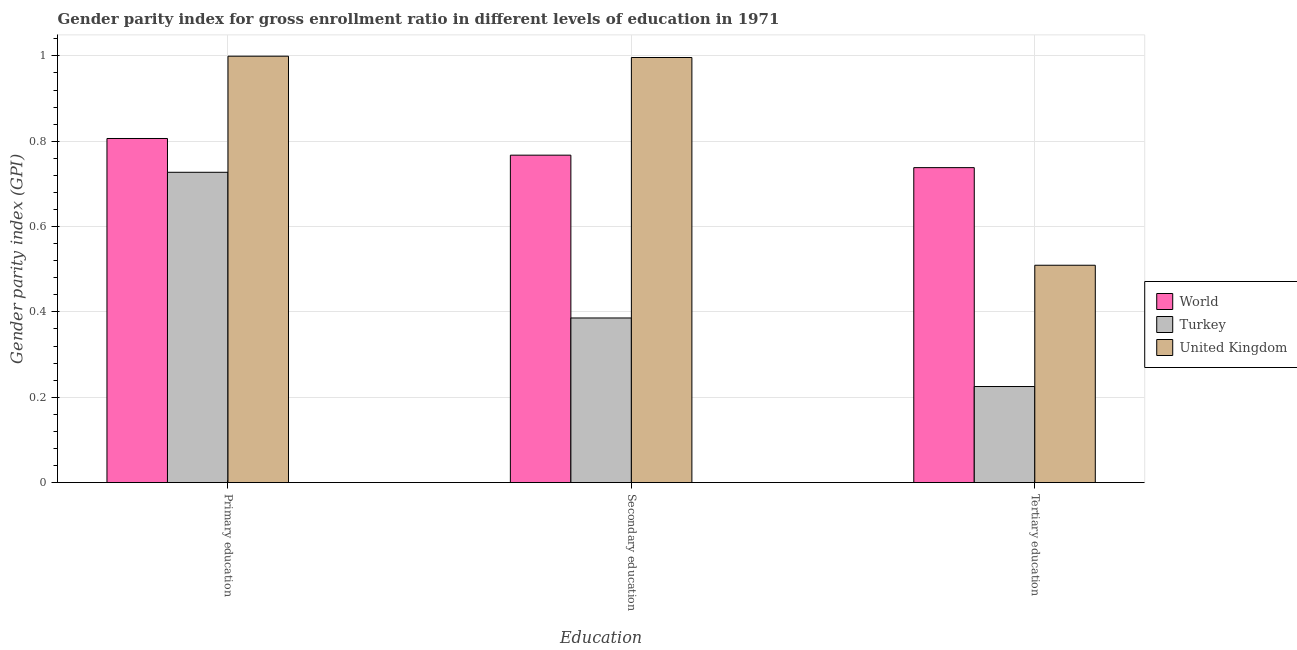How many different coloured bars are there?
Keep it short and to the point. 3. How many groups of bars are there?
Make the answer very short. 3. How many bars are there on the 3rd tick from the right?
Keep it short and to the point. 3. What is the label of the 3rd group of bars from the left?
Your answer should be very brief. Tertiary education. What is the gender parity index in primary education in United Kingdom?
Offer a terse response. 1. Across all countries, what is the maximum gender parity index in secondary education?
Your answer should be compact. 1. Across all countries, what is the minimum gender parity index in secondary education?
Provide a short and direct response. 0.39. What is the total gender parity index in primary education in the graph?
Ensure brevity in your answer.  2.53. What is the difference between the gender parity index in primary education in United Kingdom and that in World?
Ensure brevity in your answer.  0.19. What is the difference between the gender parity index in secondary education in United Kingdom and the gender parity index in primary education in Turkey?
Offer a very short reply. 0.27. What is the average gender parity index in secondary education per country?
Provide a short and direct response. 0.72. What is the difference between the gender parity index in secondary education and gender parity index in tertiary education in United Kingdom?
Give a very brief answer. 0.49. What is the ratio of the gender parity index in secondary education in United Kingdom to that in World?
Provide a succinct answer. 1.3. Is the gender parity index in tertiary education in Turkey less than that in World?
Provide a short and direct response. Yes. What is the difference between the highest and the second highest gender parity index in tertiary education?
Your answer should be very brief. 0.23. What is the difference between the highest and the lowest gender parity index in primary education?
Your answer should be very brief. 0.27. What does the 3rd bar from the right in Primary education represents?
Your response must be concise. World. Is it the case that in every country, the sum of the gender parity index in primary education and gender parity index in secondary education is greater than the gender parity index in tertiary education?
Make the answer very short. Yes. Are all the bars in the graph horizontal?
Offer a very short reply. No. What is the difference between two consecutive major ticks on the Y-axis?
Make the answer very short. 0.2. Does the graph contain grids?
Provide a short and direct response. Yes. Where does the legend appear in the graph?
Make the answer very short. Center right. How many legend labels are there?
Keep it short and to the point. 3. What is the title of the graph?
Make the answer very short. Gender parity index for gross enrollment ratio in different levels of education in 1971. What is the label or title of the X-axis?
Offer a terse response. Education. What is the label or title of the Y-axis?
Provide a succinct answer. Gender parity index (GPI). What is the Gender parity index (GPI) of World in Primary education?
Offer a terse response. 0.81. What is the Gender parity index (GPI) in Turkey in Primary education?
Make the answer very short. 0.73. What is the Gender parity index (GPI) of United Kingdom in Primary education?
Offer a terse response. 1. What is the Gender parity index (GPI) of World in Secondary education?
Your response must be concise. 0.77. What is the Gender parity index (GPI) of Turkey in Secondary education?
Your response must be concise. 0.39. What is the Gender parity index (GPI) in United Kingdom in Secondary education?
Your answer should be very brief. 1. What is the Gender parity index (GPI) in World in Tertiary education?
Your response must be concise. 0.74. What is the Gender parity index (GPI) of Turkey in Tertiary education?
Your answer should be very brief. 0.23. What is the Gender parity index (GPI) of United Kingdom in Tertiary education?
Your response must be concise. 0.51. Across all Education, what is the maximum Gender parity index (GPI) in World?
Your response must be concise. 0.81. Across all Education, what is the maximum Gender parity index (GPI) in Turkey?
Make the answer very short. 0.73. Across all Education, what is the maximum Gender parity index (GPI) of United Kingdom?
Your answer should be compact. 1. Across all Education, what is the minimum Gender parity index (GPI) of World?
Make the answer very short. 0.74. Across all Education, what is the minimum Gender parity index (GPI) in Turkey?
Offer a terse response. 0.23. Across all Education, what is the minimum Gender parity index (GPI) of United Kingdom?
Provide a succinct answer. 0.51. What is the total Gender parity index (GPI) of World in the graph?
Your response must be concise. 2.31. What is the total Gender parity index (GPI) of Turkey in the graph?
Your response must be concise. 1.34. What is the total Gender parity index (GPI) in United Kingdom in the graph?
Provide a short and direct response. 2.5. What is the difference between the Gender parity index (GPI) of World in Primary education and that in Secondary education?
Make the answer very short. 0.04. What is the difference between the Gender parity index (GPI) in Turkey in Primary education and that in Secondary education?
Offer a very short reply. 0.34. What is the difference between the Gender parity index (GPI) of United Kingdom in Primary education and that in Secondary education?
Keep it short and to the point. 0. What is the difference between the Gender parity index (GPI) in World in Primary education and that in Tertiary education?
Your answer should be compact. 0.07. What is the difference between the Gender parity index (GPI) of Turkey in Primary education and that in Tertiary education?
Provide a short and direct response. 0.5. What is the difference between the Gender parity index (GPI) of United Kingdom in Primary education and that in Tertiary education?
Offer a very short reply. 0.49. What is the difference between the Gender parity index (GPI) in World in Secondary education and that in Tertiary education?
Provide a short and direct response. 0.03. What is the difference between the Gender parity index (GPI) in Turkey in Secondary education and that in Tertiary education?
Keep it short and to the point. 0.16. What is the difference between the Gender parity index (GPI) in United Kingdom in Secondary education and that in Tertiary education?
Offer a very short reply. 0.49. What is the difference between the Gender parity index (GPI) in World in Primary education and the Gender parity index (GPI) in Turkey in Secondary education?
Provide a short and direct response. 0.42. What is the difference between the Gender parity index (GPI) of World in Primary education and the Gender parity index (GPI) of United Kingdom in Secondary education?
Make the answer very short. -0.19. What is the difference between the Gender parity index (GPI) in Turkey in Primary education and the Gender parity index (GPI) in United Kingdom in Secondary education?
Your response must be concise. -0.27. What is the difference between the Gender parity index (GPI) of World in Primary education and the Gender parity index (GPI) of Turkey in Tertiary education?
Keep it short and to the point. 0.58. What is the difference between the Gender parity index (GPI) in World in Primary education and the Gender parity index (GPI) in United Kingdom in Tertiary education?
Make the answer very short. 0.3. What is the difference between the Gender parity index (GPI) of Turkey in Primary education and the Gender parity index (GPI) of United Kingdom in Tertiary education?
Provide a succinct answer. 0.22. What is the difference between the Gender parity index (GPI) in World in Secondary education and the Gender parity index (GPI) in Turkey in Tertiary education?
Provide a succinct answer. 0.54. What is the difference between the Gender parity index (GPI) in World in Secondary education and the Gender parity index (GPI) in United Kingdom in Tertiary education?
Offer a very short reply. 0.26. What is the difference between the Gender parity index (GPI) of Turkey in Secondary education and the Gender parity index (GPI) of United Kingdom in Tertiary education?
Provide a short and direct response. -0.12. What is the average Gender parity index (GPI) in World per Education?
Offer a terse response. 0.77. What is the average Gender parity index (GPI) in Turkey per Education?
Make the answer very short. 0.45. What is the average Gender parity index (GPI) in United Kingdom per Education?
Offer a very short reply. 0.83. What is the difference between the Gender parity index (GPI) in World and Gender parity index (GPI) in Turkey in Primary education?
Your response must be concise. 0.08. What is the difference between the Gender parity index (GPI) of World and Gender parity index (GPI) of United Kingdom in Primary education?
Offer a terse response. -0.19. What is the difference between the Gender parity index (GPI) in Turkey and Gender parity index (GPI) in United Kingdom in Primary education?
Your answer should be very brief. -0.27. What is the difference between the Gender parity index (GPI) in World and Gender parity index (GPI) in Turkey in Secondary education?
Your answer should be compact. 0.38. What is the difference between the Gender parity index (GPI) in World and Gender parity index (GPI) in United Kingdom in Secondary education?
Offer a very short reply. -0.23. What is the difference between the Gender parity index (GPI) in Turkey and Gender parity index (GPI) in United Kingdom in Secondary education?
Ensure brevity in your answer.  -0.61. What is the difference between the Gender parity index (GPI) in World and Gender parity index (GPI) in Turkey in Tertiary education?
Provide a short and direct response. 0.51. What is the difference between the Gender parity index (GPI) in World and Gender parity index (GPI) in United Kingdom in Tertiary education?
Provide a succinct answer. 0.23. What is the difference between the Gender parity index (GPI) of Turkey and Gender parity index (GPI) of United Kingdom in Tertiary education?
Give a very brief answer. -0.28. What is the ratio of the Gender parity index (GPI) in World in Primary education to that in Secondary education?
Keep it short and to the point. 1.05. What is the ratio of the Gender parity index (GPI) of Turkey in Primary education to that in Secondary education?
Provide a succinct answer. 1.89. What is the ratio of the Gender parity index (GPI) in World in Primary education to that in Tertiary education?
Give a very brief answer. 1.09. What is the ratio of the Gender parity index (GPI) of Turkey in Primary education to that in Tertiary education?
Your answer should be very brief. 3.23. What is the ratio of the Gender parity index (GPI) in United Kingdom in Primary education to that in Tertiary education?
Offer a terse response. 1.96. What is the ratio of the Gender parity index (GPI) of World in Secondary education to that in Tertiary education?
Your answer should be very brief. 1.04. What is the ratio of the Gender parity index (GPI) of Turkey in Secondary education to that in Tertiary education?
Provide a succinct answer. 1.71. What is the ratio of the Gender parity index (GPI) in United Kingdom in Secondary education to that in Tertiary education?
Provide a short and direct response. 1.96. What is the difference between the highest and the second highest Gender parity index (GPI) in World?
Keep it short and to the point. 0.04. What is the difference between the highest and the second highest Gender parity index (GPI) of Turkey?
Provide a succinct answer. 0.34. What is the difference between the highest and the second highest Gender parity index (GPI) in United Kingdom?
Offer a very short reply. 0. What is the difference between the highest and the lowest Gender parity index (GPI) in World?
Your response must be concise. 0.07. What is the difference between the highest and the lowest Gender parity index (GPI) in Turkey?
Offer a very short reply. 0.5. What is the difference between the highest and the lowest Gender parity index (GPI) of United Kingdom?
Your response must be concise. 0.49. 